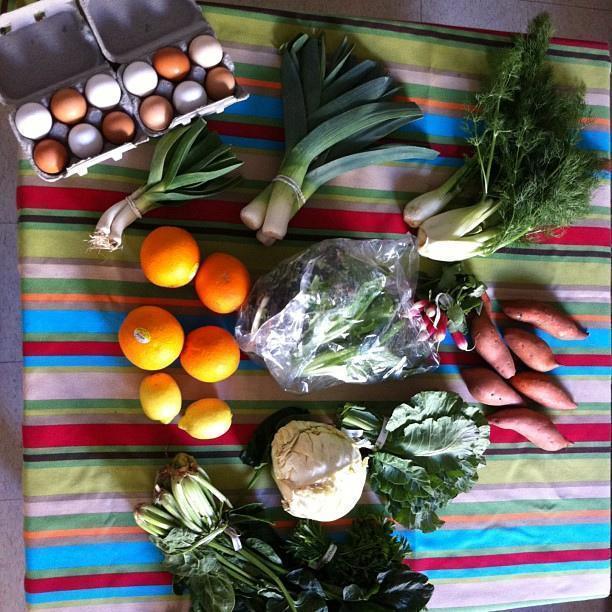What are the objects placed on?
Select the accurate answer and provide explanation: 'Answer: answer
Rationale: rationale.'
Options: Floor, sofa, towel, paper. Answer: towel.
Rationale: The objects are placed on a brightly colored towel. 